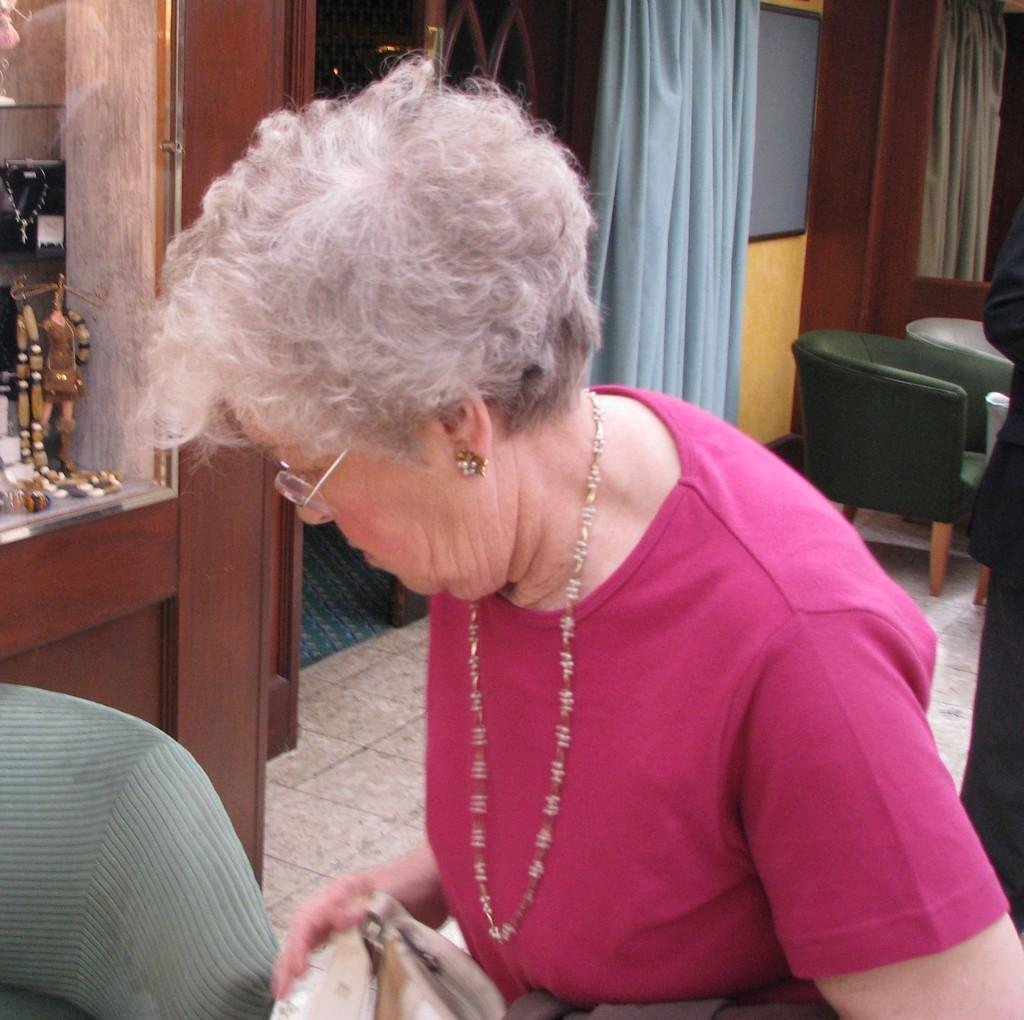Who is present in the image? There is a woman in the image. What is the woman wearing on her face? The woman is wearing spectacles. What type of furniture can be seen in the image? There are chairs in the image. What type of window treatment is present in the image? There is a curtain in the image. What part of the room is visible in the image? The floor is visible in the image. What type of lettuce is the woman holding in her hands in the image? There is no lettuce or hands visible in the image; the woman is wearing spectacles and there are chairs and a curtain present. 